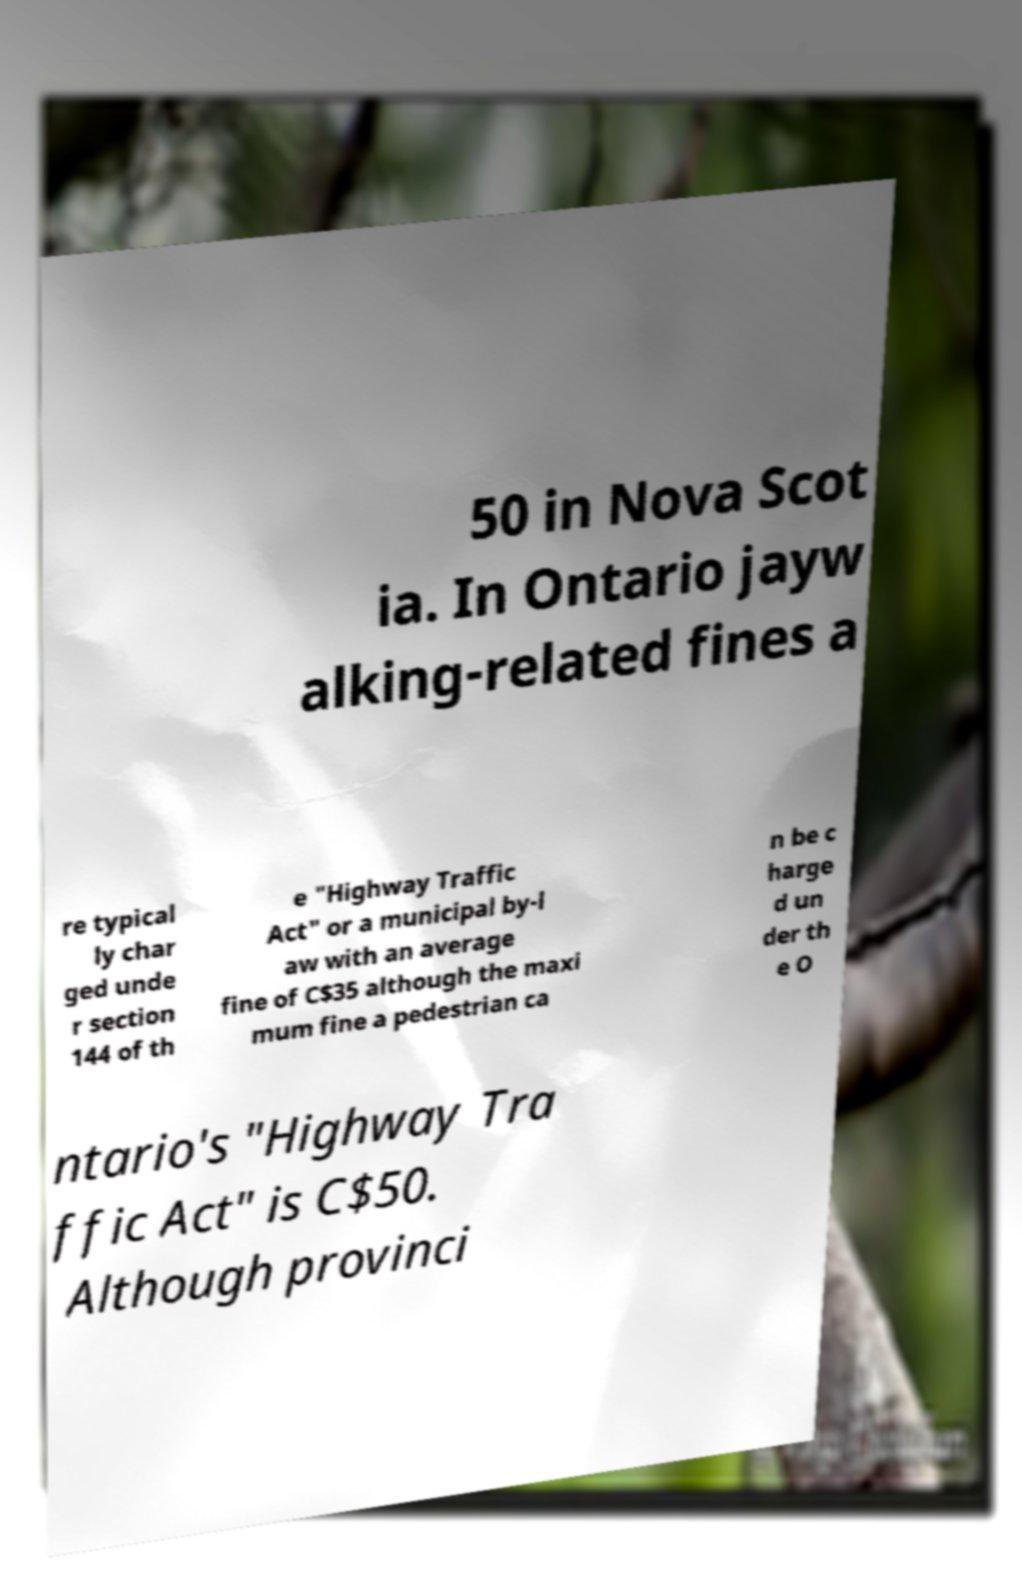Please read and relay the text visible in this image. What does it say? 50 in Nova Scot ia. In Ontario jayw alking-related fines a re typical ly char ged unde r section 144 of th e "Highway Traffic Act" or a municipal by-l aw with an average fine of C$35 although the maxi mum fine a pedestrian ca n be c harge d un der th e O ntario's "Highway Tra ffic Act" is C$50. Although provinci 